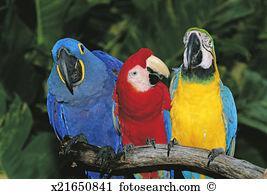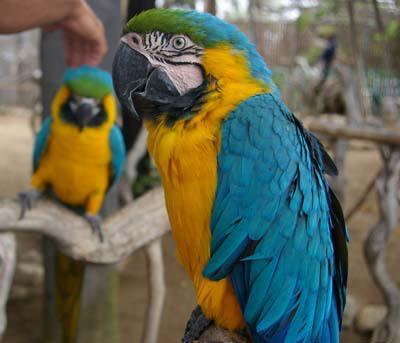The first image is the image on the left, the second image is the image on the right. For the images shown, is this caption "There are no less than three parrots resting on a branch." true? Answer yes or no. Yes. The first image is the image on the left, the second image is the image on the right. Considering the images on both sides, is "There are exactly four birds in total." valid? Answer yes or no. No. 